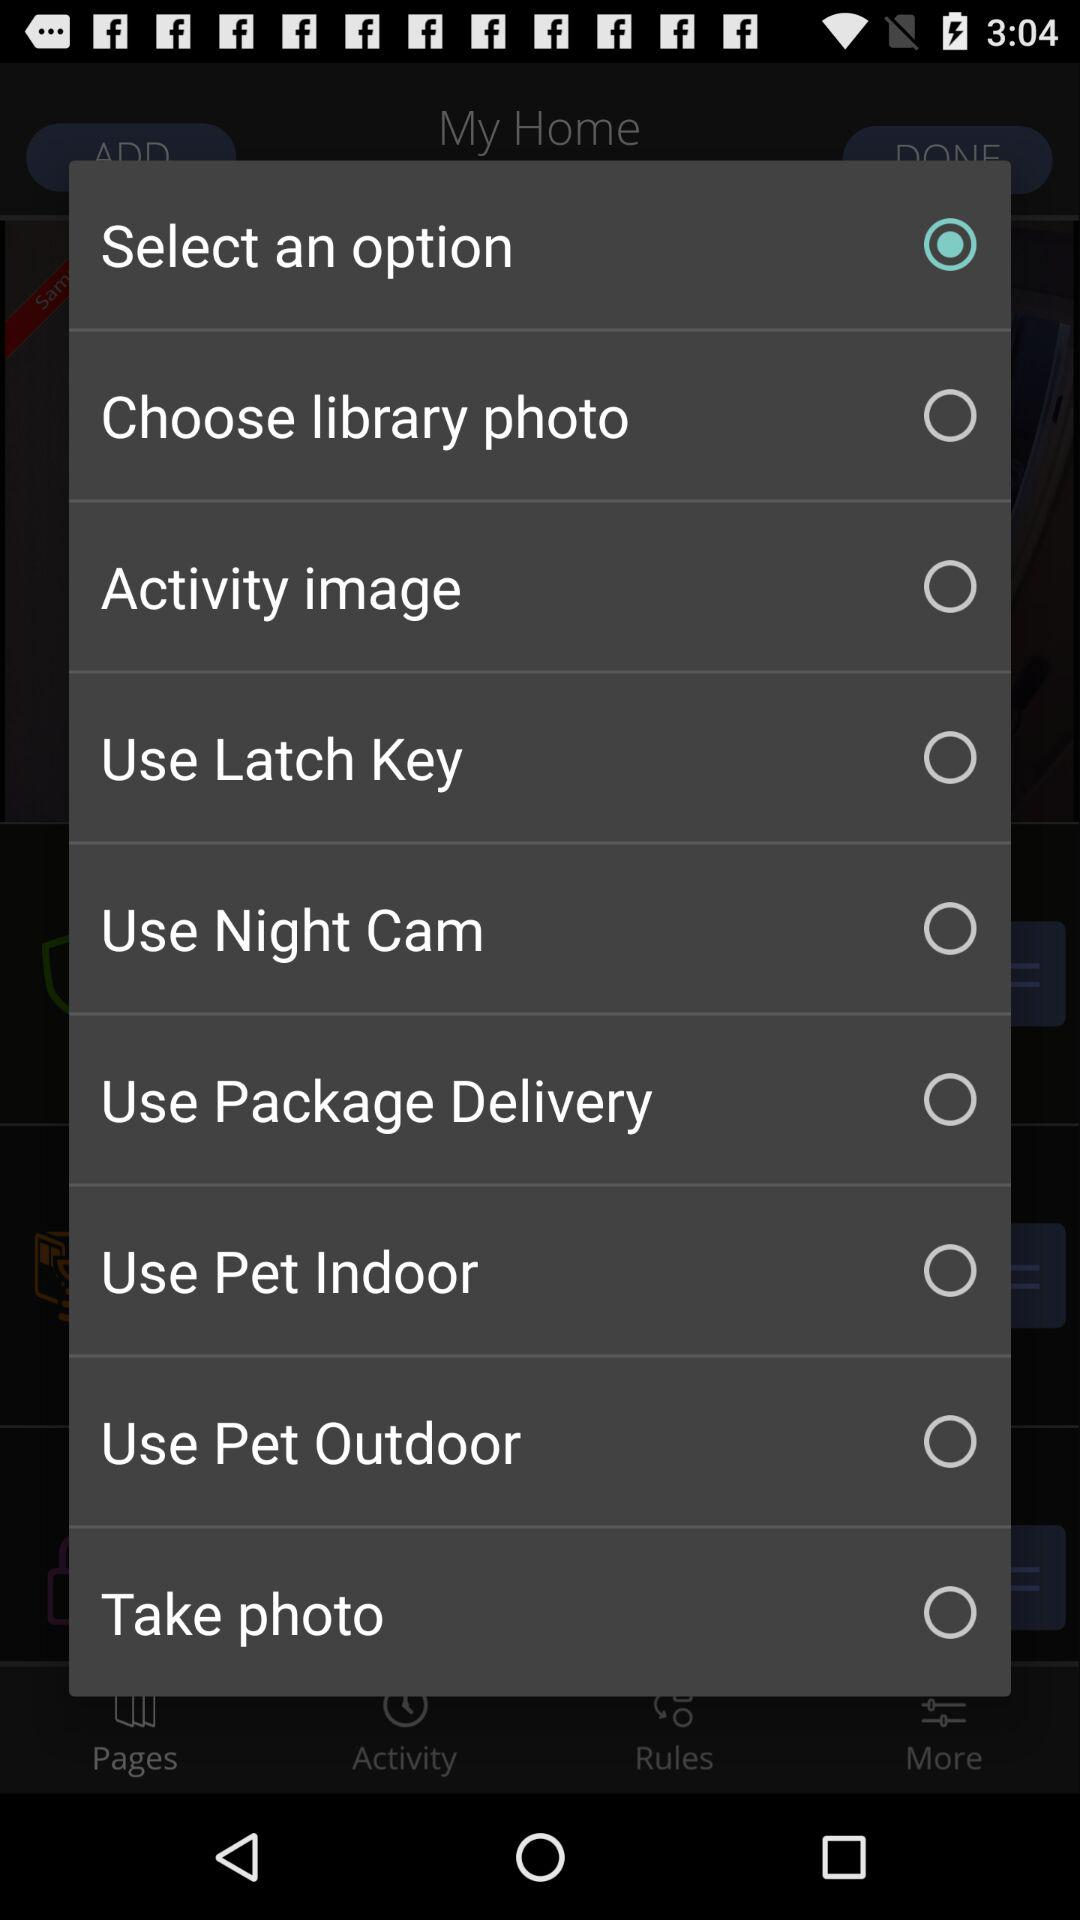Is "Take photo" selected or not? It is not selected. 